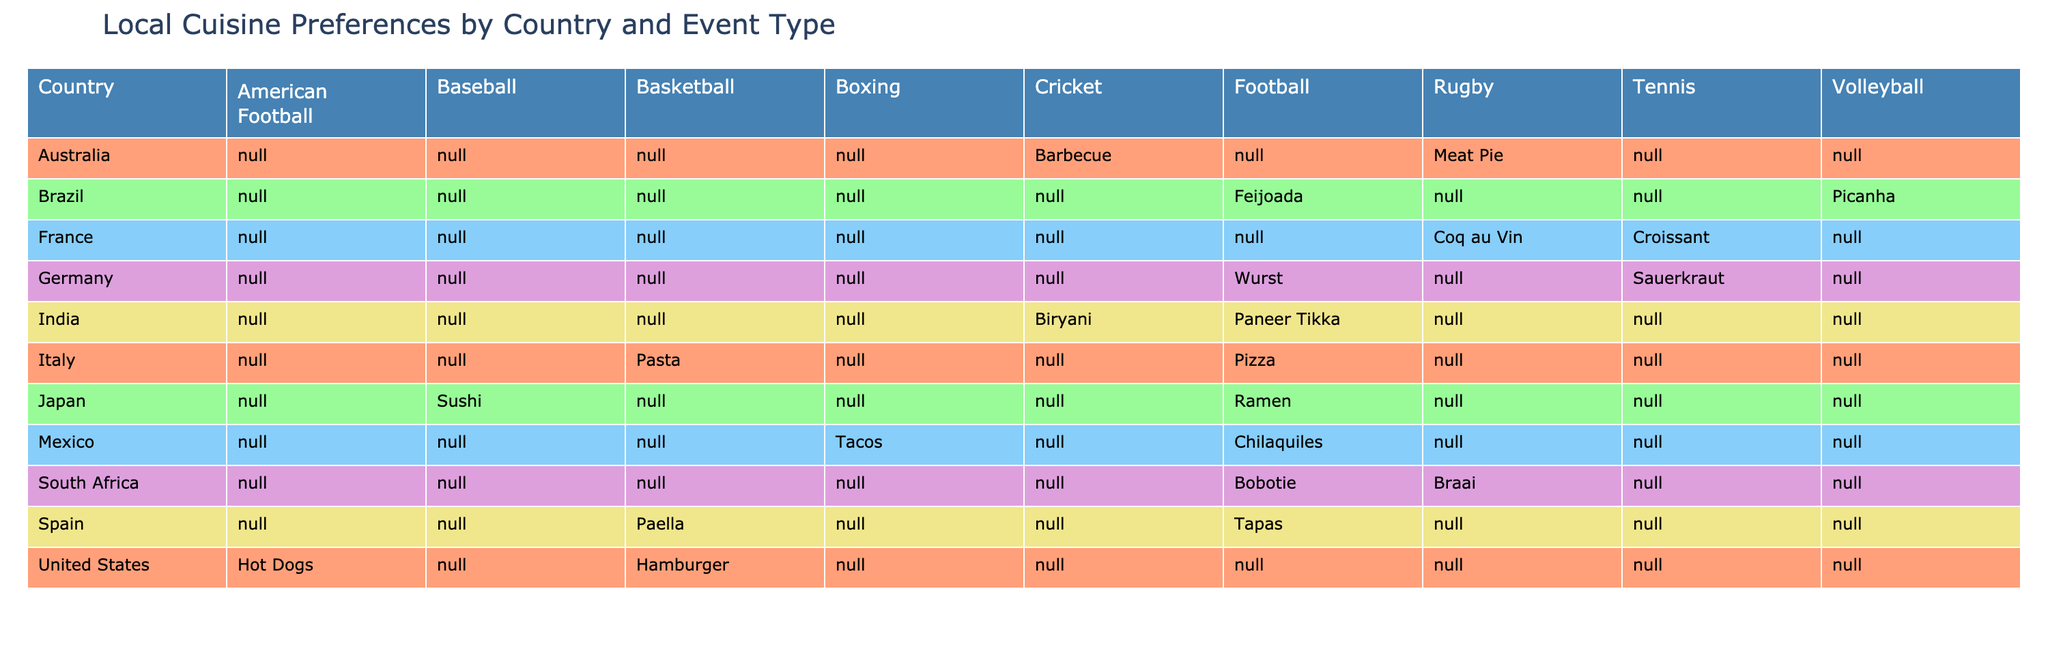What is the cuisine preference for football in Brazil? The table indicates that Brazil's cuisine preference for football is Feijoada. You can find this information by looking at the row for Brazil and finding the corresponding column for Football.
Answer: Feijoada Which country has the cuisine preference of Tapas for football events? The table shows that Spain has the preference for Tapas when it comes to football. By checking the row for Spain and the column for Football, Tapas is the listed cuisine option.
Answer: Spain Do India and Japan both have a cuisine preference for Football? Yes, both countries have specific cuisine preferences for Football; India prefers Paneer Tikka and Japan prefers Ramen. The table lists cuisine preferences next to their respective countries and event types.
Answer: Yes How many different cuisines are preferred for Rugby events, and what are they? The total number of different cuisines for Rugby events can be determined by counting the unique items listed under the Rugby column. The table indicates two distinct cuisines: Coq au Vin (France) and Braai (South Africa). Therefore, there are two unique preferences.
Answer: Two (Coq au Vin, Braai) Which event type has the most diverse range of cuisine preferences based on the table? By reviewing each event type's column, we can count the number of unique preferences for each. Football has eight different cuisines, while other events like Basketball and Rugby have fewer options. Therefore, Football has the most diverse range.
Answer: Football Is there any cuisine preference listed for Volleyball in countries other than Brazil? No, based on the table, Brazil is the only country that has a cuisine preference listed for Volleyball, which is Picanha. No other countries have preferences for Volleyball listed.
Answer: No 